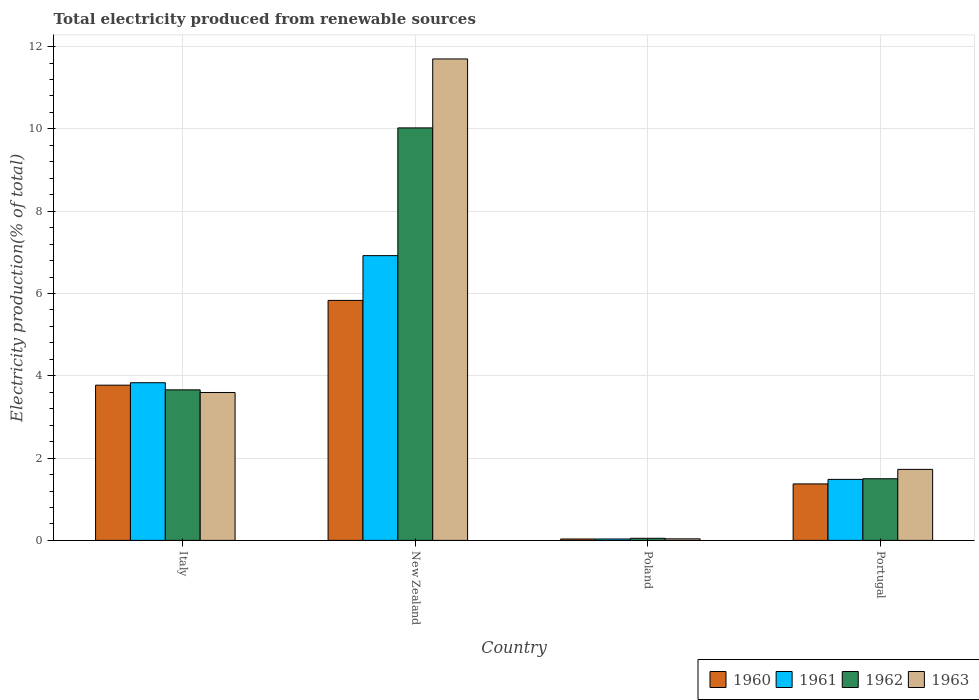How many different coloured bars are there?
Provide a short and direct response. 4. How many groups of bars are there?
Provide a succinct answer. 4. Are the number of bars on each tick of the X-axis equal?
Offer a terse response. Yes. How many bars are there on the 3rd tick from the left?
Your answer should be compact. 4. How many bars are there on the 1st tick from the right?
Ensure brevity in your answer.  4. What is the label of the 2nd group of bars from the left?
Provide a short and direct response. New Zealand. What is the total electricity produced in 1960 in Italy?
Your answer should be very brief. 3.77. Across all countries, what is the maximum total electricity produced in 1960?
Keep it short and to the point. 5.83. Across all countries, what is the minimum total electricity produced in 1962?
Your answer should be compact. 0.05. In which country was the total electricity produced in 1962 maximum?
Offer a terse response. New Zealand. What is the total total electricity produced in 1961 in the graph?
Offer a terse response. 12.27. What is the difference between the total electricity produced in 1960 in Italy and that in Poland?
Your answer should be compact. 3.74. What is the difference between the total electricity produced in 1963 in Portugal and the total electricity produced in 1961 in Poland?
Provide a succinct answer. 1.69. What is the average total electricity produced in 1961 per country?
Your answer should be very brief. 3.07. What is the difference between the total electricity produced of/in 1963 and total electricity produced of/in 1962 in New Zealand?
Make the answer very short. 1.68. In how many countries, is the total electricity produced in 1960 greater than 4 %?
Make the answer very short. 1. What is the ratio of the total electricity produced in 1962 in Italy to that in Poland?
Offer a terse response. 71.88. Is the difference between the total electricity produced in 1963 in Italy and Portugal greater than the difference between the total electricity produced in 1962 in Italy and Portugal?
Provide a short and direct response. No. What is the difference between the highest and the second highest total electricity produced in 1962?
Make the answer very short. -8.53. What is the difference between the highest and the lowest total electricity produced in 1960?
Your response must be concise. 5.8. Is it the case that in every country, the sum of the total electricity produced in 1962 and total electricity produced in 1960 is greater than the sum of total electricity produced in 1961 and total electricity produced in 1963?
Make the answer very short. No. What does the 1st bar from the right in Poland represents?
Provide a succinct answer. 1963. How many countries are there in the graph?
Offer a very short reply. 4. Are the values on the major ticks of Y-axis written in scientific E-notation?
Keep it short and to the point. No. Does the graph contain grids?
Keep it short and to the point. Yes. Where does the legend appear in the graph?
Provide a short and direct response. Bottom right. How many legend labels are there?
Ensure brevity in your answer.  4. How are the legend labels stacked?
Your answer should be very brief. Horizontal. What is the title of the graph?
Provide a succinct answer. Total electricity produced from renewable sources. Does "1967" appear as one of the legend labels in the graph?
Ensure brevity in your answer.  No. What is the label or title of the X-axis?
Provide a short and direct response. Country. What is the Electricity production(% of total) of 1960 in Italy?
Keep it short and to the point. 3.77. What is the Electricity production(% of total) in 1961 in Italy?
Your answer should be very brief. 3.83. What is the Electricity production(% of total) of 1962 in Italy?
Ensure brevity in your answer.  3.66. What is the Electricity production(% of total) of 1963 in Italy?
Provide a succinct answer. 3.59. What is the Electricity production(% of total) of 1960 in New Zealand?
Your answer should be compact. 5.83. What is the Electricity production(% of total) of 1961 in New Zealand?
Your answer should be compact. 6.92. What is the Electricity production(% of total) of 1962 in New Zealand?
Make the answer very short. 10.02. What is the Electricity production(% of total) in 1963 in New Zealand?
Your answer should be compact. 11.7. What is the Electricity production(% of total) of 1960 in Poland?
Make the answer very short. 0.03. What is the Electricity production(% of total) in 1961 in Poland?
Your answer should be compact. 0.03. What is the Electricity production(% of total) of 1962 in Poland?
Provide a short and direct response. 0.05. What is the Electricity production(% of total) in 1963 in Poland?
Provide a short and direct response. 0.04. What is the Electricity production(% of total) in 1960 in Portugal?
Ensure brevity in your answer.  1.37. What is the Electricity production(% of total) in 1961 in Portugal?
Give a very brief answer. 1.48. What is the Electricity production(% of total) in 1962 in Portugal?
Your answer should be compact. 1.5. What is the Electricity production(% of total) in 1963 in Portugal?
Offer a terse response. 1.73. Across all countries, what is the maximum Electricity production(% of total) of 1960?
Keep it short and to the point. 5.83. Across all countries, what is the maximum Electricity production(% of total) in 1961?
Offer a very short reply. 6.92. Across all countries, what is the maximum Electricity production(% of total) of 1962?
Keep it short and to the point. 10.02. Across all countries, what is the maximum Electricity production(% of total) in 1963?
Provide a succinct answer. 11.7. Across all countries, what is the minimum Electricity production(% of total) of 1960?
Give a very brief answer. 0.03. Across all countries, what is the minimum Electricity production(% of total) in 1961?
Make the answer very short. 0.03. Across all countries, what is the minimum Electricity production(% of total) of 1962?
Your answer should be compact. 0.05. Across all countries, what is the minimum Electricity production(% of total) of 1963?
Offer a terse response. 0.04. What is the total Electricity production(% of total) of 1960 in the graph?
Your response must be concise. 11.01. What is the total Electricity production(% of total) of 1961 in the graph?
Provide a succinct answer. 12.27. What is the total Electricity production(% of total) in 1962 in the graph?
Make the answer very short. 15.23. What is the total Electricity production(% of total) in 1963 in the graph?
Your answer should be very brief. 17.06. What is the difference between the Electricity production(% of total) of 1960 in Italy and that in New Zealand?
Ensure brevity in your answer.  -2.06. What is the difference between the Electricity production(% of total) in 1961 in Italy and that in New Zealand?
Give a very brief answer. -3.09. What is the difference between the Electricity production(% of total) in 1962 in Italy and that in New Zealand?
Your answer should be compact. -6.37. What is the difference between the Electricity production(% of total) of 1963 in Italy and that in New Zealand?
Offer a very short reply. -8.11. What is the difference between the Electricity production(% of total) of 1960 in Italy and that in Poland?
Make the answer very short. 3.74. What is the difference between the Electricity production(% of total) of 1961 in Italy and that in Poland?
Your answer should be compact. 3.8. What is the difference between the Electricity production(% of total) of 1962 in Italy and that in Poland?
Your answer should be very brief. 3.61. What is the difference between the Electricity production(% of total) of 1963 in Italy and that in Poland?
Keep it short and to the point. 3.56. What is the difference between the Electricity production(% of total) of 1960 in Italy and that in Portugal?
Give a very brief answer. 2.4. What is the difference between the Electricity production(% of total) in 1961 in Italy and that in Portugal?
Ensure brevity in your answer.  2.35. What is the difference between the Electricity production(% of total) in 1962 in Italy and that in Portugal?
Give a very brief answer. 2.16. What is the difference between the Electricity production(% of total) in 1963 in Italy and that in Portugal?
Offer a terse response. 1.87. What is the difference between the Electricity production(% of total) in 1960 in New Zealand and that in Poland?
Provide a succinct answer. 5.8. What is the difference between the Electricity production(% of total) of 1961 in New Zealand and that in Poland?
Keep it short and to the point. 6.89. What is the difference between the Electricity production(% of total) of 1962 in New Zealand and that in Poland?
Your response must be concise. 9.97. What is the difference between the Electricity production(% of total) in 1963 in New Zealand and that in Poland?
Keep it short and to the point. 11.66. What is the difference between the Electricity production(% of total) of 1960 in New Zealand and that in Portugal?
Your answer should be compact. 4.46. What is the difference between the Electricity production(% of total) in 1961 in New Zealand and that in Portugal?
Your answer should be very brief. 5.44. What is the difference between the Electricity production(% of total) of 1962 in New Zealand and that in Portugal?
Your response must be concise. 8.53. What is the difference between the Electricity production(% of total) in 1963 in New Zealand and that in Portugal?
Provide a short and direct response. 9.97. What is the difference between the Electricity production(% of total) of 1960 in Poland and that in Portugal?
Offer a terse response. -1.34. What is the difference between the Electricity production(% of total) in 1961 in Poland and that in Portugal?
Offer a terse response. -1.45. What is the difference between the Electricity production(% of total) in 1962 in Poland and that in Portugal?
Your answer should be compact. -1.45. What is the difference between the Electricity production(% of total) of 1963 in Poland and that in Portugal?
Ensure brevity in your answer.  -1.69. What is the difference between the Electricity production(% of total) of 1960 in Italy and the Electricity production(% of total) of 1961 in New Zealand?
Ensure brevity in your answer.  -3.15. What is the difference between the Electricity production(% of total) in 1960 in Italy and the Electricity production(% of total) in 1962 in New Zealand?
Your answer should be compact. -6.25. What is the difference between the Electricity production(% of total) in 1960 in Italy and the Electricity production(% of total) in 1963 in New Zealand?
Offer a terse response. -7.93. What is the difference between the Electricity production(% of total) in 1961 in Italy and the Electricity production(% of total) in 1962 in New Zealand?
Make the answer very short. -6.19. What is the difference between the Electricity production(% of total) in 1961 in Italy and the Electricity production(% of total) in 1963 in New Zealand?
Ensure brevity in your answer.  -7.87. What is the difference between the Electricity production(% of total) of 1962 in Italy and the Electricity production(% of total) of 1963 in New Zealand?
Your answer should be compact. -8.04. What is the difference between the Electricity production(% of total) in 1960 in Italy and the Electricity production(% of total) in 1961 in Poland?
Provide a succinct answer. 3.74. What is the difference between the Electricity production(% of total) of 1960 in Italy and the Electricity production(% of total) of 1962 in Poland?
Provide a succinct answer. 3.72. What is the difference between the Electricity production(% of total) in 1960 in Italy and the Electricity production(% of total) in 1963 in Poland?
Keep it short and to the point. 3.73. What is the difference between the Electricity production(% of total) of 1961 in Italy and the Electricity production(% of total) of 1962 in Poland?
Offer a terse response. 3.78. What is the difference between the Electricity production(% of total) in 1961 in Italy and the Electricity production(% of total) in 1963 in Poland?
Provide a succinct answer. 3.79. What is the difference between the Electricity production(% of total) in 1962 in Italy and the Electricity production(% of total) in 1963 in Poland?
Provide a succinct answer. 3.62. What is the difference between the Electricity production(% of total) of 1960 in Italy and the Electricity production(% of total) of 1961 in Portugal?
Your answer should be compact. 2.29. What is the difference between the Electricity production(% of total) of 1960 in Italy and the Electricity production(% of total) of 1962 in Portugal?
Provide a short and direct response. 2.27. What is the difference between the Electricity production(% of total) in 1960 in Italy and the Electricity production(% of total) in 1963 in Portugal?
Your answer should be very brief. 2.05. What is the difference between the Electricity production(% of total) in 1961 in Italy and the Electricity production(% of total) in 1962 in Portugal?
Your answer should be compact. 2.33. What is the difference between the Electricity production(% of total) of 1961 in Italy and the Electricity production(% of total) of 1963 in Portugal?
Give a very brief answer. 2.11. What is the difference between the Electricity production(% of total) in 1962 in Italy and the Electricity production(% of total) in 1963 in Portugal?
Make the answer very short. 1.93. What is the difference between the Electricity production(% of total) in 1960 in New Zealand and the Electricity production(% of total) in 1961 in Poland?
Your response must be concise. 5.8. What is the difference between the Electricity production(% of total) in 1960 in New Zealand and the Electricity production(% of total) in 1962 in Poland?
Your answer should be compact. 5.78. What is the difference between the Electricity production(% of total) of 1960 in New Zealand and the Electricity production(% of total) of 1963 in Poland?
Your answer should be compact. 5.79. What is the difference between the Electricity production(% of total) of 1961 in New Zealand and the Electricity production(% of total) of 1962 in Poland?
Offer a terse response. 6.87. What is the difference between the Electricity production(% of total) of 1961 in New Zealand and the Electricity production(% of total) of 1963 in Poland?
Your response must be concise. 6.88. What is the difference between the Electricity production(% of total) in 1962 in New Zealand and the Electricity production(% of total) in 1963 in Poland?
Keep it short and to the point. 9.99. What is the difference between the Electricity production(% of total) of 1960 in New Zealand and the Electricity production(% of total) of 1961 in Portugal?
Offer a very short reply. 4.35. What is the difference between the Electricity production(% of total) in 1960 in New Zealand and the Electricity production(% of total) in 1962 in Portugal?
Keep it short and to the point. 4.33. What is the difference between the Electricity production(% of total) in 1960 in New Zealand and the Electricity production(% of total) in 1963 in Portugal?
Offer a terse response. 4.11. What is the difference between the Electricity production(% of total) in 1961 in New Zealand and the Electricity production(% of total) in 1962 in Portugal?
Ensure brevity in your answer.  5.42. What is the difference between the Electricity production(% of total) in 1961 in New Zealand and the Electricity production(% of total) in 1963 in Portugal?
Give a very brief answer. 5.19. What is the difference between the Electricity production(% of total) in 1962 in New Zealand and the Electricity production(% of total) in 1963 in Portugal?
Provide a short and direct response. 8.3. What is the difference between the Electricity production(% of total) in 1960 in Poland and the Electricity production(% of total) in 1961 in Portugal?
Offer a terse response. -1.45. What is the difference between the Electricity production(% of total) in 1960 in Poland and the Electricity production(% of total) in 1962 in Portugal?
Provide a short and direct response. -1.46. What is the difference between the Electricity production(% of total) of 1960 in Poland and the Electricity production(% of total) of 1963 in Portugal?
Ensure brevity in your answer.  -1.69. What is the difference between the Electricity production(% of total) in 1961 in Poland and the Electricity production(% of total) in 1962 in Portugal?
Give a very brief answer. -1.46. What is the difference between the Electricity production(% of total) of 1961 in Poland and the Electricity production(% of total) of 1963 in Portugal?
Provide a succinct answer. -1.69. What is the difference between the Electricity production(% of total) in 1962 in Poland and the Electricity production(% of total) in 1963 in Portugal?
Your answer should be very brief. -1.67. What is the average Electricity production(% of total) in 1960 per country?
Keep it short and to the point. 2.75. What is the average Electricity production(% of total) of 1961 per country?
Provide a succinct answer. 3.07. What is the average Electricity production(% of total) of 1962 per country?
Your response must be concise. 3.81. What is the average Electricity production(% of total) of 1963 per country?
Keep it short and to the point. 4.26. What is the difference between the Electricity production(% of total) in 1960 and Electricity production(% of total) in 1961 in Italy?
Offer a terse response. -0.06. What is the difference between the Electricity production(% of total) of 1960 and Electricity production(% of total) of 1962 in Italy?
Make the answer very short. 0.11. What is the difference between the Electricity production(% of total) in 1960 and Electricity production(% of total) in 1963 in Italy?
Make the answer very short. 0.18. What is the difference between the Electricity production(% of total) of 1961 and Electricity production(% of total) of 1962 in Italy?
Make the answer very short. 0.17. What is the difference between the Electricity production(% of total) of 1961 and Electricity production(% of total) of 1963 in Italy?
Provide a short and direct response. 0.24. What is the difference between the Electricity production(% of total) of 1962 and Electricity production(% of total) of 1963 in Italy?
Make the answer very short. 0.06. What is the difference between the Electricity production(% of total) in 1960 and Electricity production(% of total) in 1961 in New Zealand?
Offer a very short reply. -1.09. What is the difference between the Electricity production(% of total) of 1960 and Electricity production(% of total) of 1962 in New Zealand?
Your answer should be compact. -4.19. What is the difference between the Electricity production(% of total) in 1960 and Electricity production(% of total) in 1963 in New Zealand?
Give a very brief answer. -5.87. What is the difference between the Electricity production(% of total) of 1961 and Electricity production(% of total) of 1962 in New Zealand?
Give a very brief answer. -3.1. What is the difference between the Electricity production(% of total) in 1961 and Electricity production(% of total) in 1963 in New Zealand?
Ensure brevity in your answer.  -4.78. What is the difference between the Electricity production(% of total) in 1962 and Electricity production(% of total) in 1963 in New Zealand?
Your response must be concise. -1.68. What is the difference between the Electricity production(% of total) of 1960 and Electricity production(% of total) of 1961 in Poland?
Your answer should be compact. 0. What is the difference between the Electricity production(% of total) in 1960 and Electricity production(% of total) in 1962 in Poland?
Provide a short and direct response. -0.02. What is the difference between the Electricity production(% of total) of 1960 and Electricity production(% of total) of 1963 in Poland?
Offer a terse response. -0. What is the difference between the Electricity production(% of total) in 1961 and Electricity production(% of total) in 1962 in Poland?
Offer a terse response. -0.02. What is the difference between the Electricity production(% of total) in 1961 and Electricity production(% of total) in 1963 in Poland?
Offer a terse response. -0. What is the difference between the Electricity production(% of total) of 1962 and Electricity production(% of total) of 1963 in Poland?
Keep it short and to the point. 0.01. What is the difference between the Electricity production(% of total) in 1960 and Electricity production(% of total) in 1961 in Portugal?
Ensure brevity in your answer.  -0.11. What is the difference between the Electricity production(% of total) of 1960 and Electricity production(% of total) of 1962 in Portugal?
Provide a short and direct response. -0.13. What is the difference between the Electricity production(% of total) in 1960 and Electricity production(% of total) in 1963 in Portugal?
Provide a short and direct response. -0.35. What is the difference between the Electricity production(% of total) of 1961 and Electricity production(% of total) of 1962 in Portugal?
Offer a terse response. -0.02. What is the difference between the Electricity production(% of total) in 1961 and Electricity production(% of total) in 1963 in Portugal?
Provide a short and direct response. -0.24. What is the difference between the Electricity production(% of total) of 1962 and Electricity production(% of total) of 1963 in Portugal?
Offer a very short reply. -0.23. What is the ratio of the Electricity production(% of total) in 1960 in Italy to that in New Zealand?
Ensure brevity in your answer.  0.65. What is the ratio of the Electricity production(% of total) in 1961 in Italy to that in New Zealand?
Your response must be concise. 0.55. What is the ratio of the Electricity production(% of total) in 1962 in Italy to that in New Zealand?
Provide a succinct answer. 0.36. What is the ratio of the Electricity production(% of total) of 1963 in Italy to that in New Zealand?
Your response must be concise. 0.31. What is the ratio of the Electricity production(% of total) in 1960 in Italy to that in Poland?
Your answer should be very brief. 110.45. What is the ratio of the Electricity production(% of total) of 1961 in Italy to that in Poland?
Give a very brief answer. 112.3. What is the ratio of the Electricity production(% of total) of 1962 in Italy to that in Poland?
Your answer should be very brief. 71.88. What is the ratio of the Electricity production(% of total) of 1963 in Italy to that in Poland?
Offer a terse response. 94.84. What is the ratio of the Electricity production(% of total) in 1960 in Italy to that in Portugal?
Keep it short and to the point. 2.75. What is the ratio of the Electricity production(% of total) in 1961 in Italy to that in Portugal?
Offer a terse response. 2.58. What is the ratio of the Electricity production(% of total) of 1962 in Italy to that in Portugal?
Your response must be concise. 2.44. What is the ratio of the Electricity production(% of total) in 1963 in Italy to that in Portugal?
Your response must be concise. 2.08. What is the ratio of the Electricity production(% of total) of 1960 in New Zealand to that in Poland?
Keep it short and to the point. 170.79. What is the ratio of the Electricity production(% of total) of 1961 in New Zealand to that in Poland?
Provide a short and direct response. 202.83. What is the ratio of the Electricity production(% of total) of 1962 in New Zealand to that in Poland?
Offer a very short reply. 196.95. What is the ratio of the Electricity production(% of total) of 1963 in New Zealand to that in Poland?
Offer a terse response. 308.73. What is the ratio of the Electricity production(% of total) in 1960 in New Zealand to that in Portugal?
Give a very brief answer. 4.25. What is the ratio of the Electricity production(% of total) of 1961 in New Zealand to that in Portugal?
Provide a succinct answer. 4.67. What is the ratio of the Electricity production(% of total) in 1962 in New Zealand to that in Portugal?
Give a very brief answer. 6.69. What is the ratio of the Electricity production(% of total) of 1963 in New Zealand to that in Portugal?
Give a very brief answer. 6.78. What is the ratio of the Electricity production(% of total) in 1960 in Poland to that in Portugal?
Your answer should be very brief. 0.02. What is the ratio of the Electricity production(% of total) in 1961 in Poland to that in Portugal?
Your answer should be compact. 0.02. What is the ratio of the Electricity production(% of total) in 1962 in Poland to that in Portugal?
Provide a succinct answer. 0.03. What is the ratio of the Electricity production(% of total) of 1963 in Poland to that in Portugal?
Your answer should be compact. 0.02. What is the difference between the highest and the second highest Electricity production(% of total) in 1960?
Give a very brief answer. 2.06. What is the difference between the highest and the second highest Electricity production(% of total) in 1961?
Your answer should be compact. 3.09. What is the difference between the highest and the second highest Electricity production(% of total) in 1962?
Your answer should be compact. 6.37. What is the difference between the highest and the second highest Electricity production(% of total) in 1963?
Your answer should be very brief. 8.11. What is the difference between the highest and the lowest Electricity production(% of total) of 1960?
Offer a very short reply. 5.8. What is the difference between the highest and the lowest Electricity production(% of total) in 1961?
Offer a terse response. 6.89. What is the difference between the highest and the lowest Electricity production(% of total) in 1962?
Keep it short and to the point. 9.97. What is the difference between the highest and the lowest Electricity production(% of total) of 1963?
Keep it short and to the point. 11.66. 